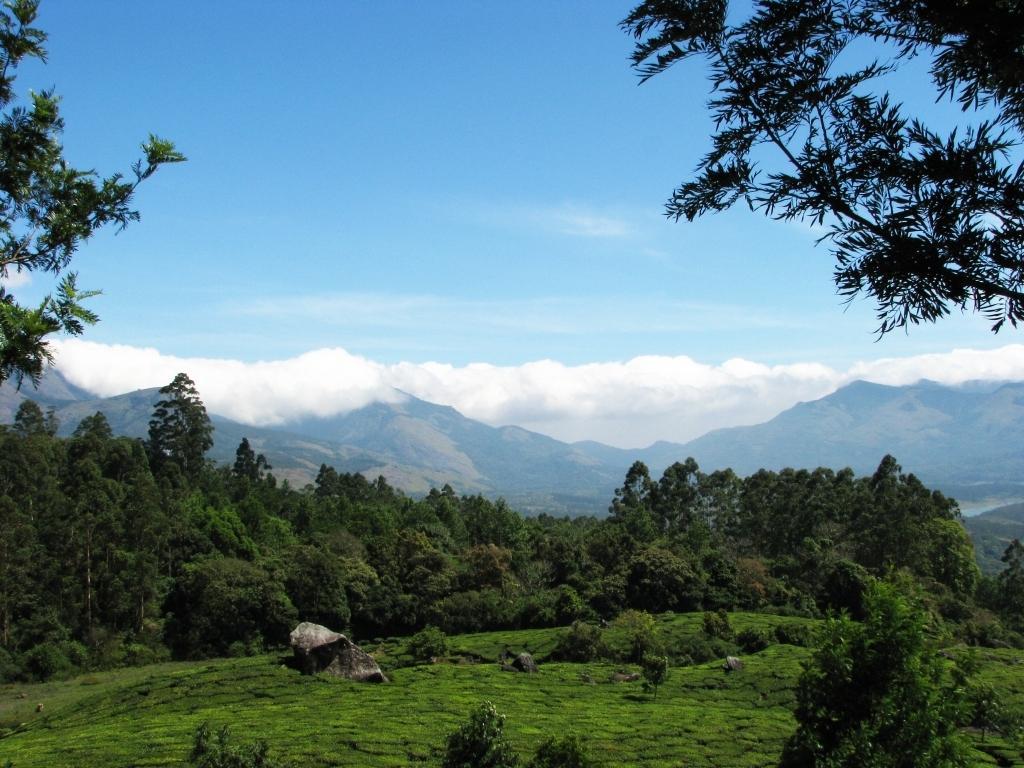Could you give a brief overview of what you see in this image? In this image we can see ground, grass, plants, rock, and trees. In the background we can see mountain and sky with clouds. 